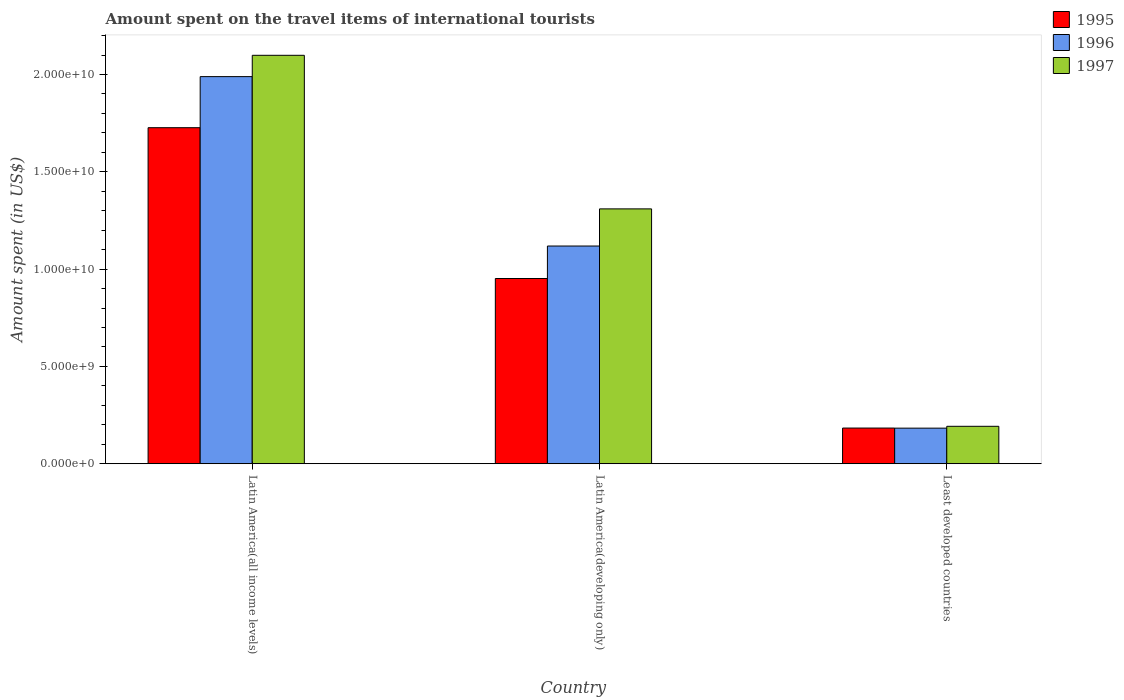How many different coloured bars are there?
Offer a terse response. 3. How many groups of bars are there?
Keep it short and to the point. 3. How many bars are there on the 1st tick from the left?
Give a very brief answer. 3. How many bars are there on the 2nd tick from the right?
Your answer should be very brief. 3. What is the label of the 3rd group of bars from the left?
Offer a terse response. Least developed countries. What is the amount spent on the travel items of international tourists in 1996 in Latin America(all income levels)?
Give a very brief answer. 1.99e+1. Across all countries, what is the maximum amount spent on the travel items of international tourists in 1996?
Keep it short and to the point. 1.99e+1. Across all countries, what is the minimum amount spent on the travel items of international tourists in 1995?
Keep it short and to the point. 1.83e+09. In which country was the amount spent on the travel items of international tourists in 1995 maximum?
Give a very brief answer. Latin America(all income levels). In which country was the amount spent on the travel items of international tourists in 1997 minimum?
Provide a succinct answer. Least developed countries. What is the total amount spent on the travel items of international tourists in 1996 in the graph?
Offer a very short reply. 3.29e+1. What is the difference between the amount spent on the travel items of international tourists in 1997 in Latin America(all income levels) and that in Least developed countries?
Offer a very short reply. 1.91e+1. What is the difference between the amount spent on the travel items of international tourists in 1995 in Latin America(all income levels) and the amount spent on the travel items of international tourists in 1996 in Latin America(developing only)?
Your response must be concise. 6.08e+09. What is the average amount spent on the travel items of international tourists in 1995 per country?
Your response must be concise. 9.54e+09. What is the difference between the amount spent on the travel items of international tourists of/in 1996 and amount spent on the travel items of international tourists of/in 1995 in Least developed countries?
Provide a short and direct response. -4.74e+06. In how many countries, is the amount spent on the travel items of international tourists in 1995 greater than 6000000000 US$?
Your answer should be compact. 2. What is the ratio of the amount spent on the travel items of international tourists in 1996 in Latin America(developing only) to that in Least developed countries?
Offer a very short reply. 6.12. Is the amount spent on the travel items of international tourists in 1996 in Latin America(all income levels) less than that in Least developed countries?
Your answer should be compact. No. What is the difference between the highest and the second highest amount spent on the travel items of international tourists in 1995?
Give a very brief answer. -7.68e+09. What is the difference between the highest and the lowest amount spent on the travel items of international tourists in 1995?
Ensure brevity in your answer.  1.54e+1. Is the sum of the amount spent on the travel items of international tourists in 1995 in Latin America(developing only) and Least developed countries greater than the maximum amount spent on the travel items of international tourists in 1996 across all countries?
Your response must be concise. No. What does the 1st bar from the right in Latin America(developing only) represents?
Your answer should be compact. 1997. Is it the case that in every country, the sum of the amount spent on the travel items of international tourists in 1995 and amount spent on the travel items of international tourists in 1997 is greater than the amount spent on the travel items of international tourists in 1996?
Provide a short and direct response. Yes. Are all the bars in the graph horizontal?
Offer a very short reply. No. Does the graph contain grids?
Provide a short and direct response. No. How many legend labels are there?
Make the answer very short. 3. How are the legend labels stacked?
Provide a short and direct response. Vertical. What is the title of the graph?
Offer a very short reply. Amount spent on the travel items of international tourists. Does "1969" appear as one of the legend labels in the graph?
Your answer should be compact. No. What is the label or title of the X-axis?
Your answer should be very brief. Country. What is the label or title of the Y-axis?
Keep it short and to the point. Amount spent (in US$). What is the Amount spent (in US$) in 1995 in Latin America(all income levels)?
Your answer should be compact. 1.73e+1. What is the Amount spent (in US$) in 1996 in Latin America(all income levels)?
Your answer should be very brief. 1.99e+1. What is the Amount spent (in US$) of 1997 in Latin America(all income levels)?
Make the answer very short. 2.10e+1. What is the Amount spent (in US$) in 1995 in Latin America(developing only)?
Offer a terse response. 9.52e+09. What is the Amount spent (in US$) in 1996 in Latin America(developing only)?
Keep it short and to the point. 1.12e+1. What is the Amount spent (in US$) in 1997 in Latin America(developing only)?
Your answer should be very brief. 1.31e+1. What is the Amount spent (in US$) of 1995 in Least developed countries?
Make the answer very short. 1.83e+09. What is the Amount spent (in US$) in 1996 in Least developed countries?
Your answer should be very brief. 1.83e+09. What is the Amount spent (in US$) in 1997 in Least developed countries?
Offer a terse response. 1.92e+09. Across all countries, what is the maximum Amount spent (in US$) of 1995?
Give a very brief answer. 1.73e+1. Across all countries, what is the maximum Amount spent (in US$) of 1996?
Offer a terse response. 1.99e+1. Across all countries, what is the maximum Amount spent (in US$) in 1997?
Ensure brevity in your answer.  2.10e+1. Across all countries, what is the minimum Amount spent (in US$) in 1995?
Provide a short and direct response. 1.83e+09. Across all countries, what is the minimum Amount spent (in US$) of 1996?
Your answer should be compact. 1.83e+09. Across all countries, what is the minimum Amount spent (in US$) in 1997?
Your response must be concise. 1.92e+09. What is the total Amount spent (in US$) in 1995 in the graph?
Offer a very short reply. 2.86e+1. What is the total Amount spent (in US$) of 1996 in the graph?
Your answer should be very brief. 3.29e+1. What is the total Amount spent (in US$) in 1997 in the graph?
Make the answer very short. 3.60e+1. What is the difference between the Amount spent (in US$) of 1995 in Latin America(all income levels) and that in Latin America(developing only)?
Provide a succinct answer. 7.75e+09. What is the difference between the Amount spent (in US$) of 1996 in Latin America(all income levels) and that in Latin America(developing only)?
Your response must be concise. 8.70e+09. What is the difference between the Amount spent (in US$) in 1997 in Latin America(all income levels) and that in Latin America(developing only)?
Offer a very short reply. 7.89e+09. What is the difference between the Amount spent (in US$) in 1995 in Latin America(all income levels) and that in Least developed countries?
Your answer should be compact. 1.54e+1. What is the difference between the Amount spent (in US$) in 1996 in Latin America(all income levels) and that in Least developed countries?
Make the answer very short. 1.81e+1. What is the difference between the Amount spent (in US$) of 1997 in Latin America(all income levels) and that in Least developed countries?
Your answer should be compact. 1.91e+1. What is the difference between the Amount spent (in US$) in 1995 in Latin America(developing only) and that in Least developed countries?
Provide a short and direct response. 7.68e+09. What is the difference between the Amount spent (in US$) in 1996 in Latin America(developing only) and that in Least developed countries?
Keep it short and to the point. 9.36e+09. What is the difference between the Amount spent (in US$) of 1997 in Latin America(developing only) and that in Least developed countries?
Offer a very short reply. 1.12e+1. What is the difference between the Amount spent (in US$) of 1995 in Latin America(all income levels) and the Amount spent (in US$) of 1996 in Latin America(developing only)?
Offer a very short reply. 6.08e+09. What is the difference between the Amount spent (in US$) of 1995 in Latin America(all income levels) and the Amount spent (in US$) of 1997 in Latin America(developing only)?
Provide a short and direct response. 4.17e+09. What is the difference between the Amount spent (in US$) of 1996 in Latin America(all income levels) and the Amount spent (in US$) of 1997 in Latin America(developing only)?
Offer a very short reply. 6.80e+09. What is the difference between the Amount spent (in US$) of 1995 in Latin America(all income levels) and the Amount spent (in US$) of 1996 in Least developed countries?
Offer a terse response. 1.54e+1. What is the difference between the Amount spent (in US$) in 1995 in Latin America(all income levels) and the Amount spent (in US$) in 1997 in Least developed countries?
Provide a short and direct response. 1.53e+1. What is the difference between the Amount spent (in US$) in 1996 in Latin America(all income levels) and the Amount spent (in US$) in 1997 in Least developed countries?
Your answer should be compact. 1.80e+1. What is the difference between the Amount spent (in US$) in 1995 in Latin America(developing only) and the Amount spent (in US$) in 1996 in Least developed countries?
Make the answer very short. 7.69e+09. What is the difference between the Amount spent (in US$) in 1995 in Latin America(developing only) and the Amount spent (in US$) in 1997 in Least developed countries?
Your answer should be very brief. 7.59e+09. What is the difference between the Amount spent (in US$) in 1996 in Latin America(developing only) and the Amount spent (in US$) in 1997 in Least developed countries?
Your answer should be very brief. 9.26e+09. What is the average Amount spent (in US$) of 1995 per country?
Ensure brevity in your answer.  9.54e+09. What is the average Amount spent (in US$) of 1996 per country?
Provide a short and direct response. 1.10e+1. What is the average Amount spent (in US$) of 1997 per country?
Keep it short and to the point. 1.20e+1. What is the difference between the Amount spent (in US$) in 1995 and Amount spent (in US$) in 1996 in Latin America(all income levels)?
Give a very brief answer. -2.62e+09. What is the difference between the Amount spent (in US$) in 1995 and Amount spent (in US$) in 1997 in Latin America(all income levels)?
Give a very brief answer. -3.72e+09. What is the difference between the Amount spent (in US$) in 1996 and Amount spent (in US$) in 1997 in Latin America(all income levels)?
Provide a succinct answer. -1.10e+09. What is the difference between the Amount spent (in US$) of 1995 and Amount spent (in US$) of 1996 in Latin America(developing only)?
Offer a very short reply. -1.67e+09. What is the difference between the Amount spent (in US$) of 1995 and Amount spent (in US$) of 1997 in Latin America(developing only)?
Provide a short and direct response. -3.58e+09. What is the difference between the Amount spent (in US$) of 1996 and Amount spent (in US$) of 1997 in Latin America(developing only)?
Your answer should be compact. -1.91e+09. What is the difference between the Amount spent (in US$) in 1995 and Amount spent (in US$) in 1996 in Least developed countries?
Offer a terse response. 4.74e+06. What is the difference between the Amount spent (in US$) of 1995 and Amount spent (in US$) of 1997 in Least developed countries?
Your answer should be very brief. -9.00e+07. What is the difference between the Amount spent (in US$) in 1996 and Amount spent (in US$) in 1997 in Least developed countries?
Offer a terse response. -9.47e+07. What is the ratio of the Amount spent (in US$) of 1995 in Latin America(all income levels) to that in Latin America(developing only)?
Your answer should be compact. 1.81. What is the ratio of the Amount spent (in US$) in 1996 in Latin America(all income levels) to that in Latin America(developing only)?
Make the answer very short. 1.78. What is the ratio of the Amount spent (in US$) of 1997 in Latin America(all income levels) to that in Latin America(developing only)?
Provide a short and direct response. 1.6. What is the ratio of the Amount spent (in US$) in 1995 in Latin America(all income levels) to that in Least developed countries?
Make the answer very short. 9.42. What is the ratio of the Amount spent (in US$) of 1996 in Latin America(all income levels) to that in Least developed countries?
Your answer should be very brief. 10.88. What is the ratio of the Amount spent (in US$) in 1997 in Latin America(all income levels) to that in Least developed countries?
Offer a terse response. 10.91. What is the ratio of the Amount spent (in US$) of 1995 in Latin America(developing only) to that in Least developed countries?
Offer a very short reply. 5.19. What is the ratio of the Amount spent (in US$) of 1996 in Latin America(developing only) to that in Least developed countries?
Make the answer very short. 6.12. What is the ratio of the Amount spent (in US$) in 1997 in Latin America(developing only) to that in Least developed countries?
Provide a succinct answer. 6.81. What is the difference between the highest and the second highest Amount spent (in US$) of 1995?
Your answer should be compact. 7.75e+09. What is the difference between the highest and the second highest Amount spent (in US$) in 1996?
Ensure brevity in your answer.  8.70e+09. What is the difference between the highest and the second highest Amount spent (in US$) in 1997?
Offer a very short reply. 7.89e+09. What is the difference between the highest and the lowest Amount spent (in US$) in 1995?
Provide a succinct answer. 1.54e+1. What is the difference between the highest and the lowest Amount spent (in US$) in 1996?
Make the answer very short. 1.81e+1. What is the difference between the highest and the lowest Amount spent (in US$) in 1997?
Your answer should be compact. 1.91e+1. 